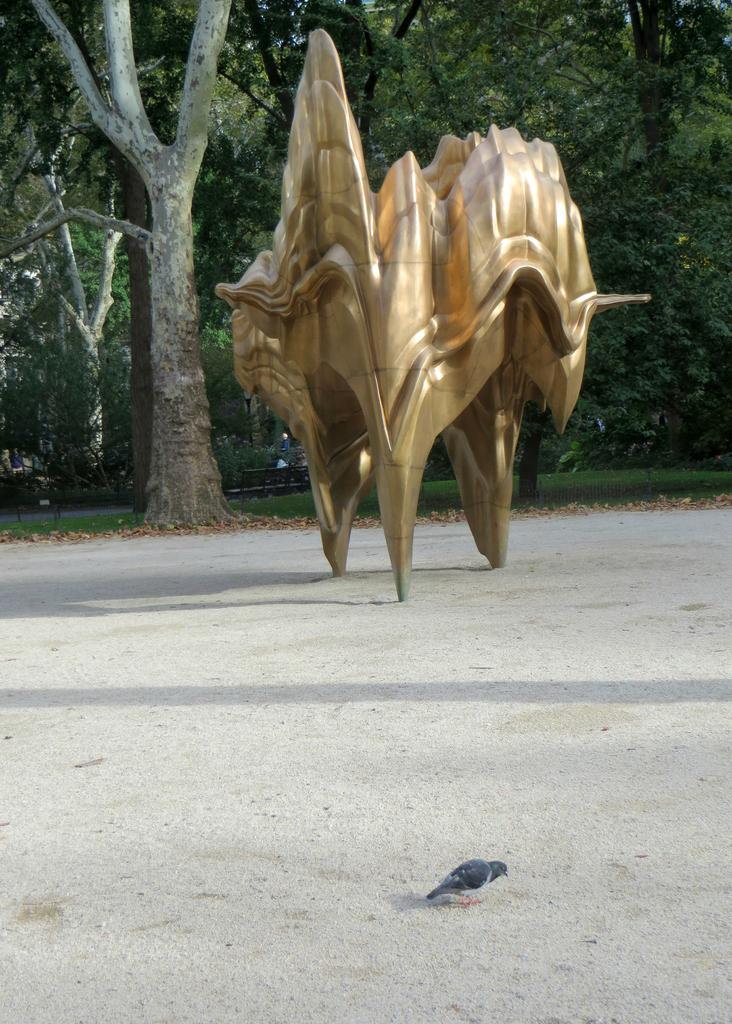What type of sculpture is depicted in the image? The sculpture is modern and in the shape of a bird. What is the color of the sculpture? The sculpture is gold in color. What can be seen in the background of the image? There are trees with branches and leaves in the image, as well as a bench. How many circles can be seen in the sculpture? There are no circles present in the sculpture; it is in the shape of a bird. What type of rock is the sculpture made of? The sculpture is not made of rock; it is made of a material that appears to be gold in color. 